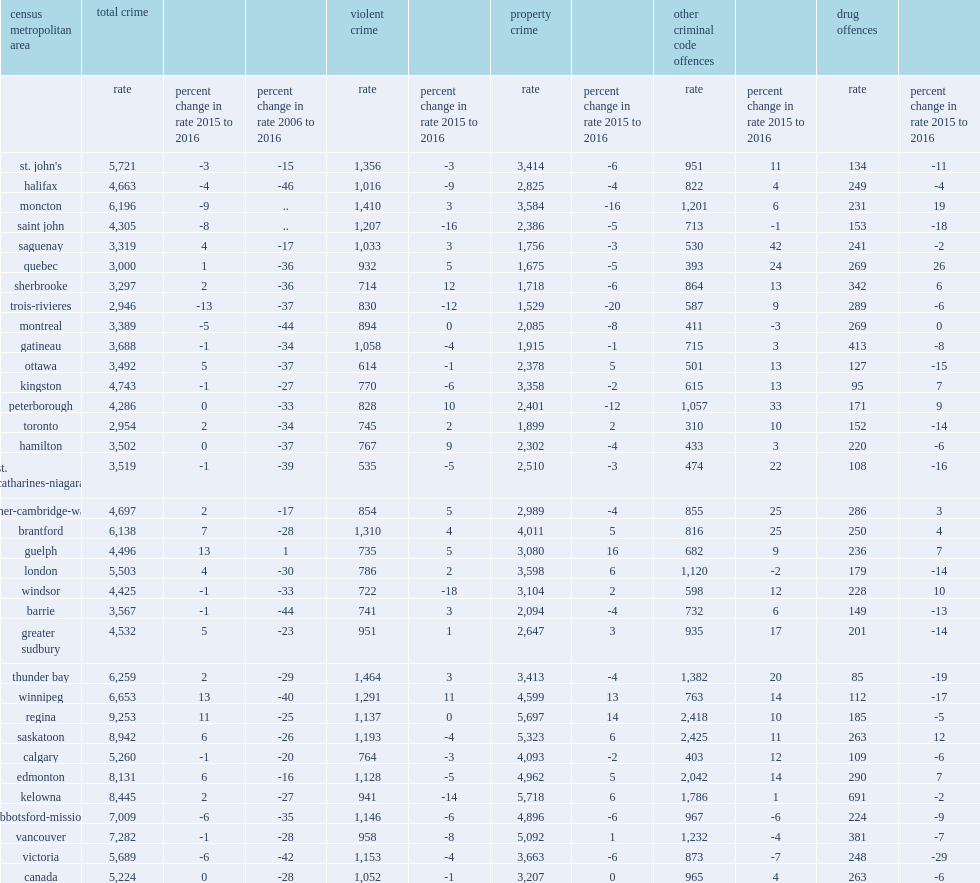Which seven cmas also had the highest police-reported crime rates in 2016? Regina saskatoon kelowna edmonton vancouver abbotsford-mission winnipeg. 